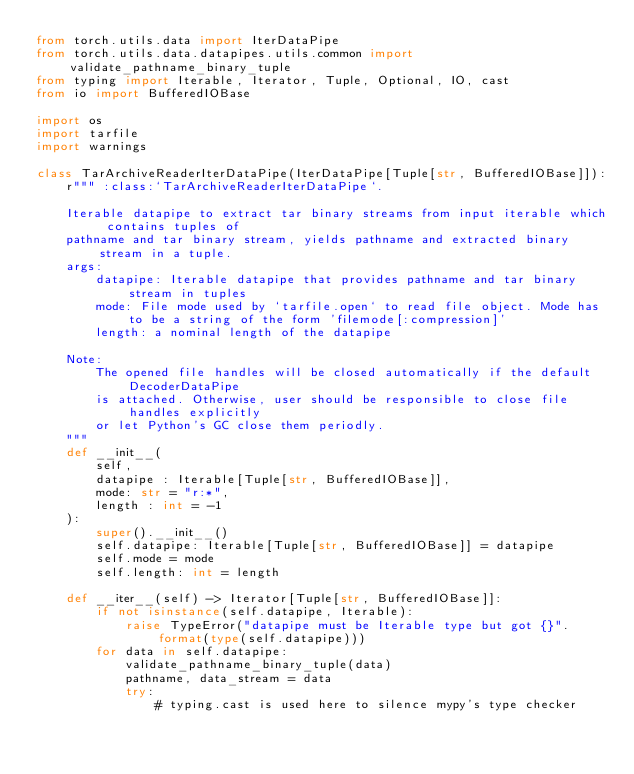<code> <loc_0><loc_0><loc_500><loc_500><_Python_>from torch.utils.data import IterDataPipe
from torch.utils.data.datapipes.utils.common import validate_pathname_binary_tuple
from typing import Iterable, Iterator, Tuple, Optional, IO, cast
from io import BufferedIOBase

import os
import tarfile
import warnings

class TarArchiveReaderIterDataPipe(IterDataPipe[Tuple[str, BufferedIOBase]]):
    r""" :class:`TarArchiveReaderIterDataPipe`.

    Iterable datapipe to extract tar binary streams from input iterable which contains tuples of
    pathname and tar binary stream, yields pathname and extracted binary stream in a tuple.
    args:
        datapipe: Iterable datapipe that provides pathname and tar binary stream in tuples
        mode: File mode used by `tarfile.open` to read file object. Mode has to be a string of the form 'filemode[:compression]'
        length: a nominal length of the datapipe

    Note:
        The opened file handles will be closed automatically if the default DecoderDataPipe
        is attached. Otherwise, user should be responsible to close file handles explicitly
        or let Python's GC close them periodly.
    """
    def __init__(
        self,
        datapipe : Iterable[Tuple[str, BufferedIOBase]],
        mode: str = "r:*",
        length : int = -1
    ):
        super().__init__()
        self.datapipe: Iterable[Tuple[str, BufferedIOBase]] = datapipe
        self.mode = mode
        self.length: int = length

    def __iter__(self) -> Iterator[Tuple[str, BufferedIOBase]]:
        if not isinstance(self.datapipe, Iterable):
            raise TypeError("datapipe must be Iterable type but got {}".format(type(self.datapipe)))
        for data in self.datapipe:
            validate_pathname_binary_tuple(data)
            pathname, data_stream = data
            try:
                # typing.cast is used here to silence mypy's type checker</code> 